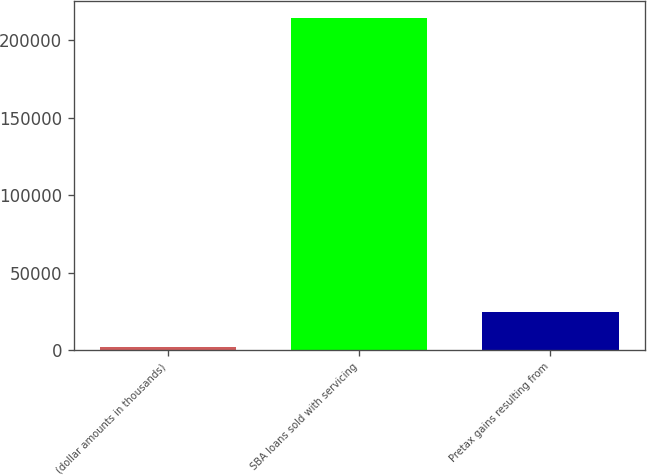<chart> <loc_0><loc_0><loc_500><loc_500><bar_chart><fcel>(dollar amounts in thousands)<fcel>SBA loans sold with servicing<fcel>Pretax gains resulting from<nl><fcel>2014<fcel>214760<fcel>24579<nl></chart> 